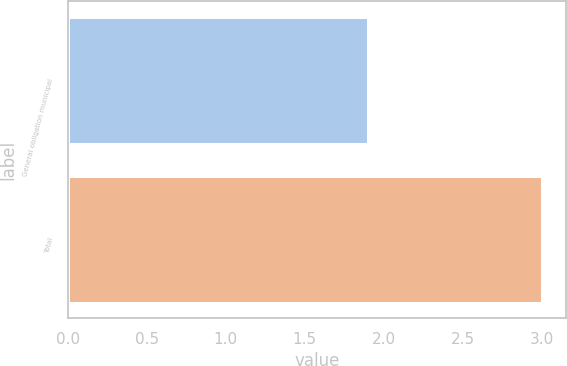Convert chart to OTSL. <chart><loc_0><loc_0><loc_500><loc_500><bar_chart><fcel>General obligation municipal<fcel>Total<nl><fcel>1.9<fcel>3<nl></chart> 